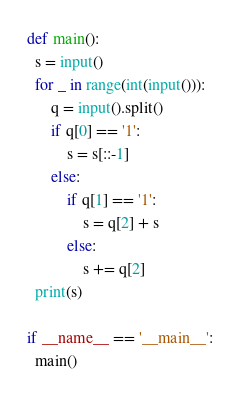<code> <loc_0><loc_0><loc_500><loc_500><_Python_>def main():
  s = input()
  for _ in range(int(input())):
      q = input().split()
      if q[0] == '1':
          s = s[::-1]
      else:
          if q[1] == '1':
              s = q[2] + s
          else:
              s += q[2]
  print(s)

if __name__ == '__main__':
  main()</code> 